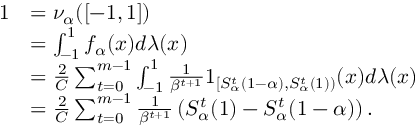Convert formula to latex. <formula><loc_0><loc_0><loc_500><loc_500>\begin{array} { r l } { 1 } & { = \nu _ { \alpha } ( [ - 1 , 1 ] ) } \\ & { = \int _ { - 1 } ^ { 1 } f _ { \alpha } ( x ) d \lambda ( x ) } \\ & { = \frac { 2 } { C } \sum _ { t = 0 } ^ { m - 1 } \int _ { - 1 } ^ { 1 } \frac { 1 } \beta ^ { t + 1 } } 1 _ { [ S _ { \alpha } ^ { t } ( 1 - \alpha ) , S _ { \alpha } ^ { t } ( 1 ) ) } ( x ) d \lambda ( x ) } \\ & { = \frac { 2 } { C } \sum _ { t = 0 } ^ { m - 1 } \frac { 1 } \beta ^ { t + 1 } } \left ( S _ { \alpha } ^ { t } ( 1 ) - S _ { \alpha } ^ { t } ( 1 - \alpha ) \right ) . } \end{array}</formula> 